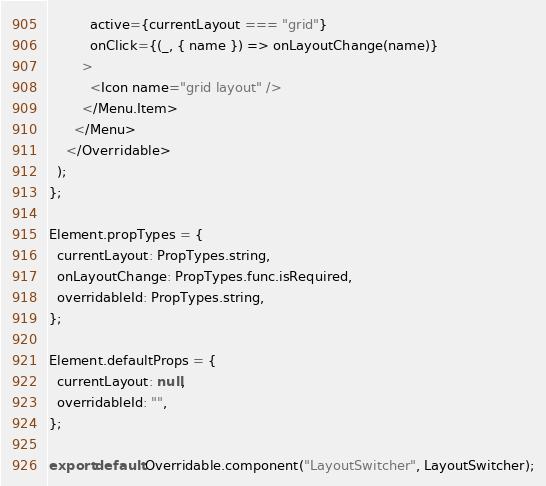<code> <loc_0><loc_0><loc_500><loc_500><_JavaScript_>          active={currentLayout === "grid"}
          onClick={(_, { name }) => onLayoutChange(name)}
        >
          <Icon name="grid layout" />
        </Menu.Item>
      </Menu>
    </Overridable>
  );
};

Element.propTypes = {
  currentLayout: PropTypes.string,
  onLayoutChange: PropTypes.func.isRequired,
  overridableId: PropTypes.string,
};

Element.defaultProps = {
  currentLayout: null,
  overridableId: "",
};

export default Overridable.component("LayoutSwitcher", LayoutSwitcher);
</code> 